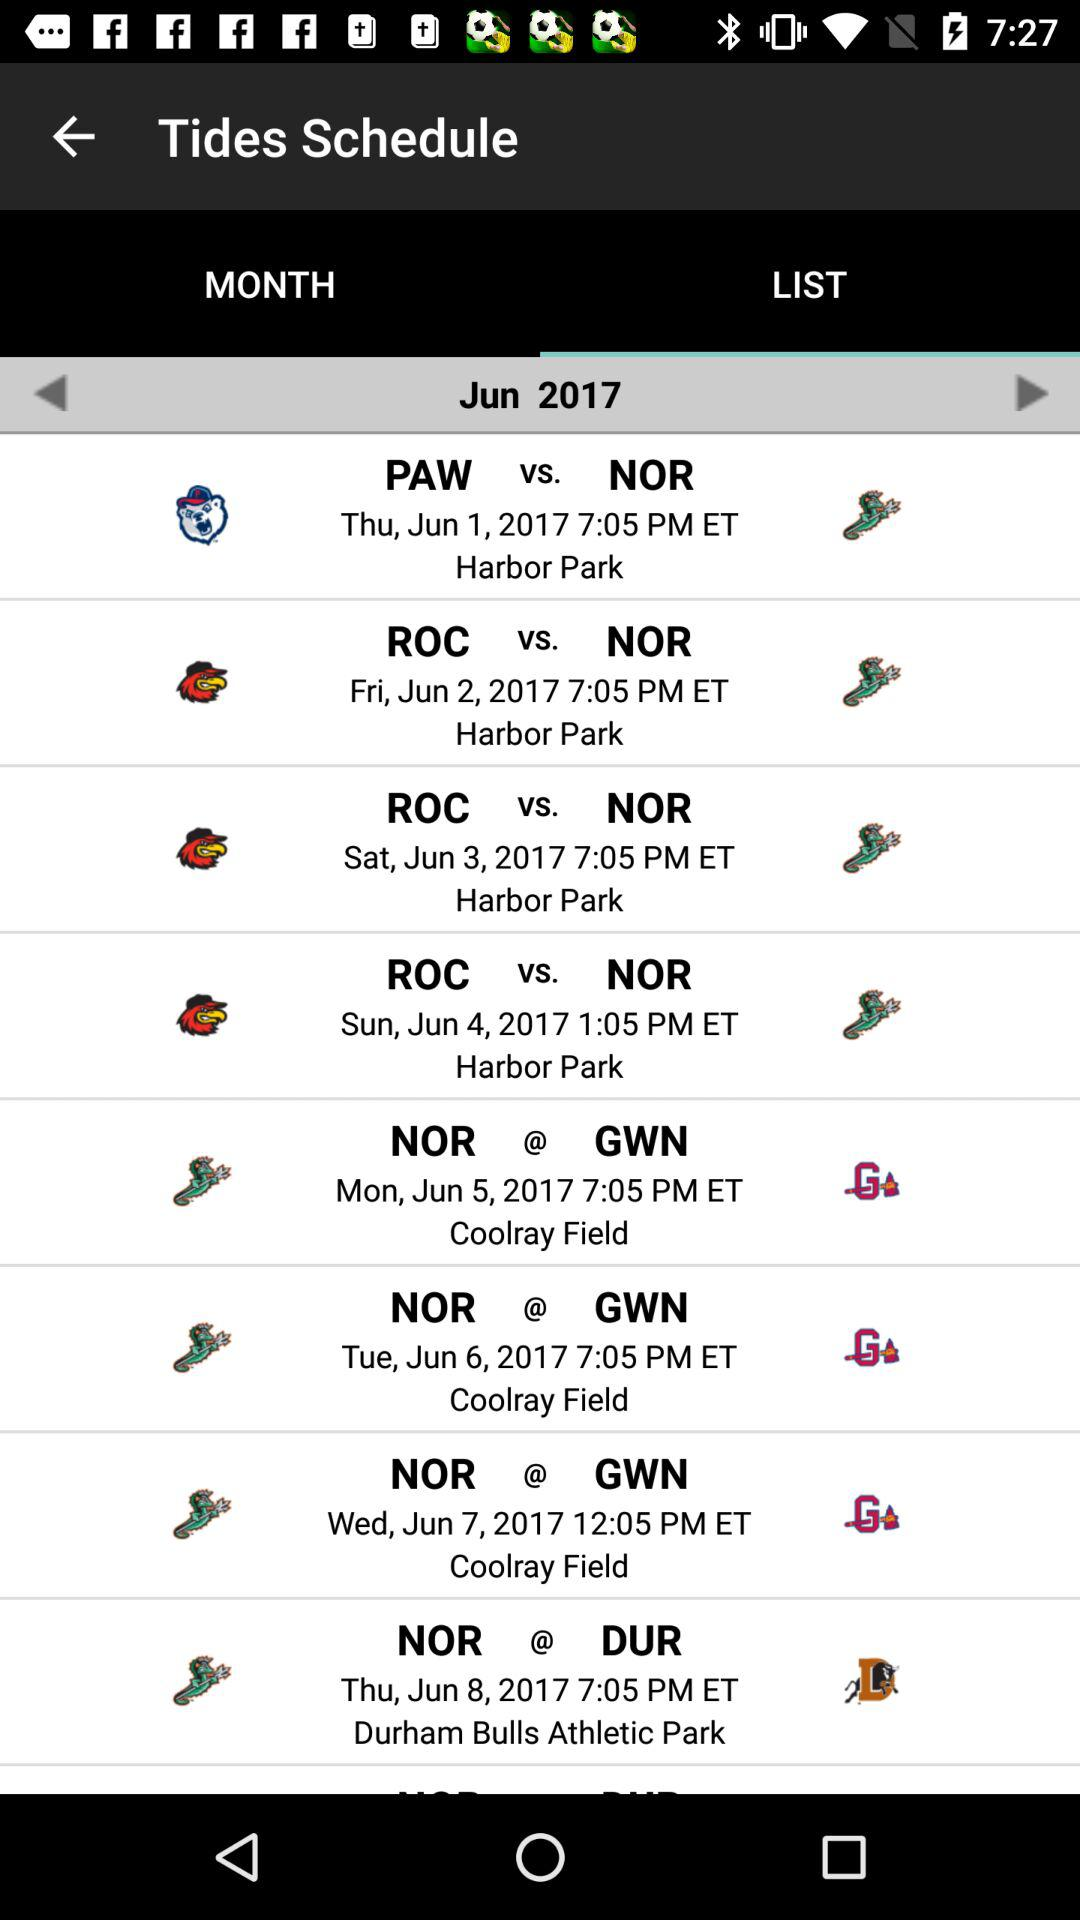Where was the match between Nor and GWN played on June 7? The match was played at Coolray Field. 